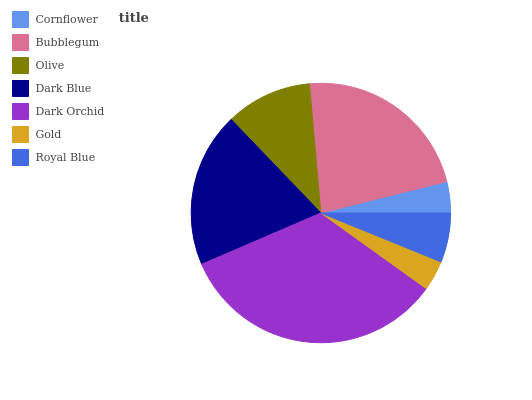Is Gold the minimum?
Answer yes or no. Yes. Is Dark Orchid the maximum?
Answer yes or no. Yes. Is Bubblegum the minimum?
Answer yes or no. No. Is Bubblegum the maximum?
Answer yes or no. No. Is Bubblegum greater than Cornflower?
Answer yes or no. Yes. Is Cornflower less than Bubblegum?
Answer yes or no. Yes. Is Cornflower greater than Bubblegum?
Answer yes or no. No. Is Bubblegum less than Cornflower?
Answer yes or no. No. Is Olive the high median?
Answer yes or no. Yes. Is Olive the low median?
Answer yes or no. Yes. Is Dark Blue the high median?
Answer yes or no. No. Is Gold the low median?
Answer yes or no. No. 